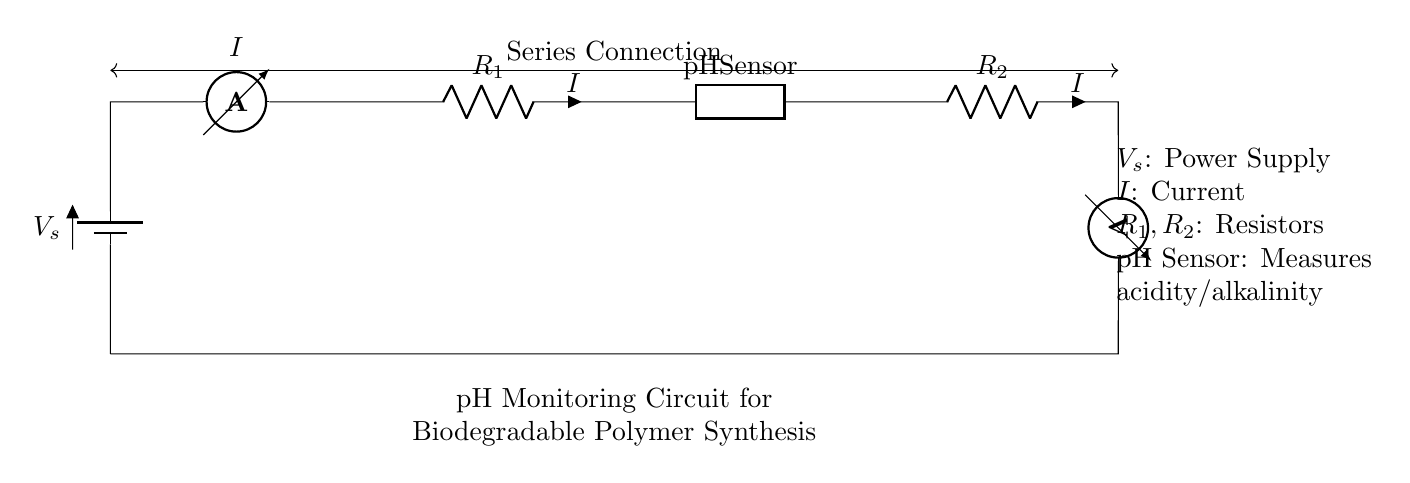What type of connection is used in this circuit? The circuit uses a series connection, where components are connected one after another in a single path for current flow. This can be observed from the diagram where each component is connected sequentially.
Answer: Series connection What component measures pH levels? The pH sensor is responsible for measuring acidity or alkalinity in the circuit. It is labeled explicitly as the pH Sensor in the diagram, indicating its function.
Answer: pH sensor What are the voltage and current labeled in the circuit? The voltage is labeled as V_s (power supply), and the current is labeled as I, which flows through all components in a series configuration. These are specified next to the respective components in the diagram.
Answer: V_s, I What is the role of R1 in the circuit? R1 is a resistor whose role is to limit the current in the circuit. In the series configuration, the same current flows through R1 and the other components, including the pH sensor.
Answer: Limit current How many resistors are present in this circuit? There are two resistors in the circuit, labeled R1 and R2, both of which play a role in managing the current flow within the series arrangement. These are visually indicated between the pH sensor and the other circuit elements.
Answer: Two What would happen to current if R1 is removed? If R1 is removed, the resistance in the circuit decreases, which would lead to an increase in current based on Ohm's Law (I = V/R). Since this is a series circuit, it’s clear that all components would then be subject to much higher current that can damage the pH sensor.
Answer: Current increase What is the purpose of a voltmeter in this circuit? The voltmeter is used to measure the voltage across certain components in the circuit, helping to monitor the electrical behavior and performance of the pH sensor and the overall circuit. It is connected in parallel to the last resistor in the series for this purpose.
Answer: Measure voltage 